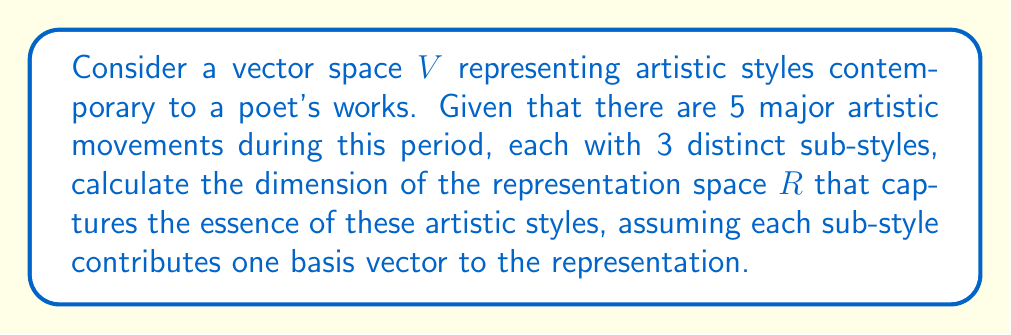What is the answer to this math problem? To solve this problem, we'll follow these steps:

1) First, let's identify the structure of our representation space:
   - We have 5 major artistic movements
   - Each movement has 3 distinct sub-styles

2) In representation theory, each distinct element that contributes to the representation typically corresponds to a basis vector in the representation space.

3) In this case, each sub-style contributes one basis vector to the representation.

4) To calculate the total number of basis vectors, and thus the dimension of the representation space, we multiply:
   $$ \text{Number of movements} \times \text{Number of sub-styles per movement} $$

5) Plugging in our values:
   $$ 5 \times 3 = 15 $$

6) Therefore, the dimension of the representation space $R$ is 15.

This 15-dimensional space can be thought of as capturing the essence of the artistic styles contemporary to the poet's works, with each dimension representing a specific sub-style within a major artistic movement.
Answer: 15 